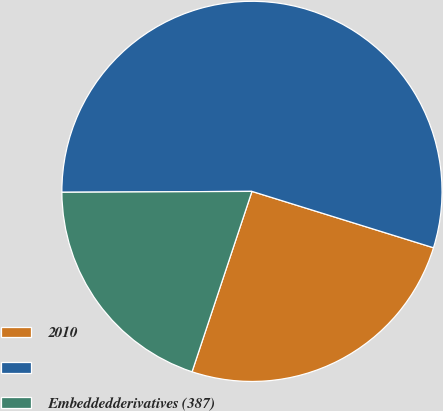<chart> <loc_0><loc_0><loc_500><loc_500><pie_chart><fcel>2010<fcel>Unnamed: 1<fcel>Embeddedderivatives (387)<nl><fcel>25.31%<fcel>54.87%<fcel>19.82%<nl></chart> 